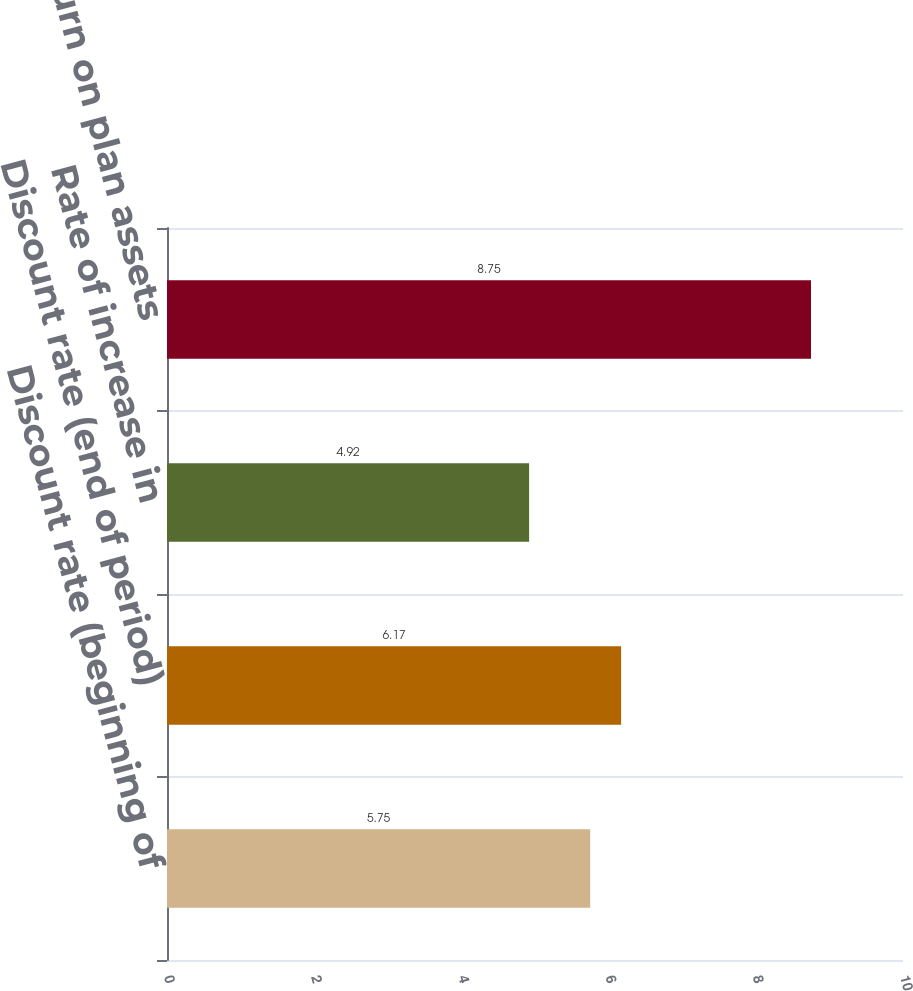<chart> <loc_0><loc_0><loc_500><loc_500><bar_chart><fcel>Discount rate (beginning of<fcel>Discount rate (end of period)<fcel>Rate of increase in<fcel>Expected return on plan assets<nl><fcel>5.75<fcel>6.17<fcel>4.92<fcel>8.75<nl></chart> 